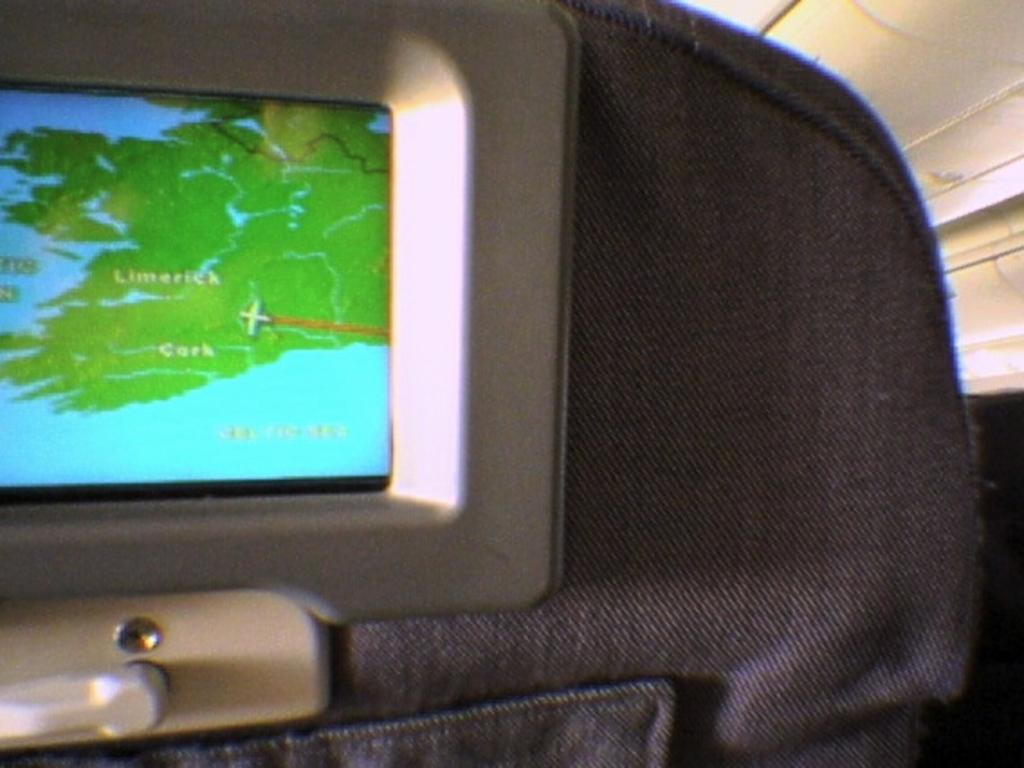What is the possible location where the image might have been taken? The image might be taken in an aeroplane. What can be seen attached to a seat in the image? There is a display attached to a seat in the image. What type of sweater is the person wearing in the image? There is no person visible in the image, and therefore no sweater can be observed. What season is depicted in the image? The image does not depict a specific season, as it is taken inside an aeroplane. Is there any agreement being signed or discussed in the image? There is no indication of any agreement being signed or discussed in the image. 